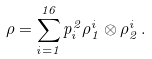Convert formula to latex. <formula><loc_0><loc_0><loc_500><loc_500>\rho = \sum _ { i = 1 } ^ { 1 6 } p ^ { 2 } _ { i } \rho _ { 1 } ^ { i } \otimes \rho _ { 2 } ^ { i } \, .</formula> 